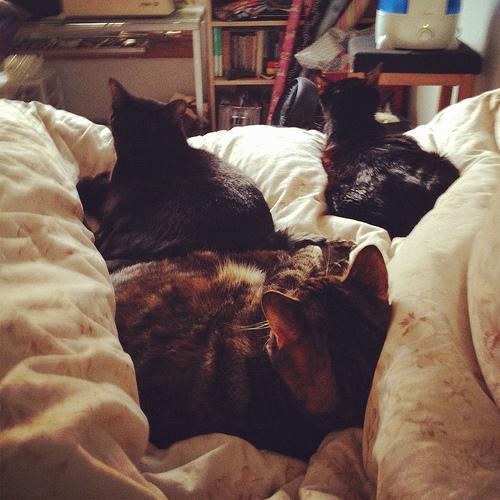How many cats on the bed?
Give a very brief answer. 3. 